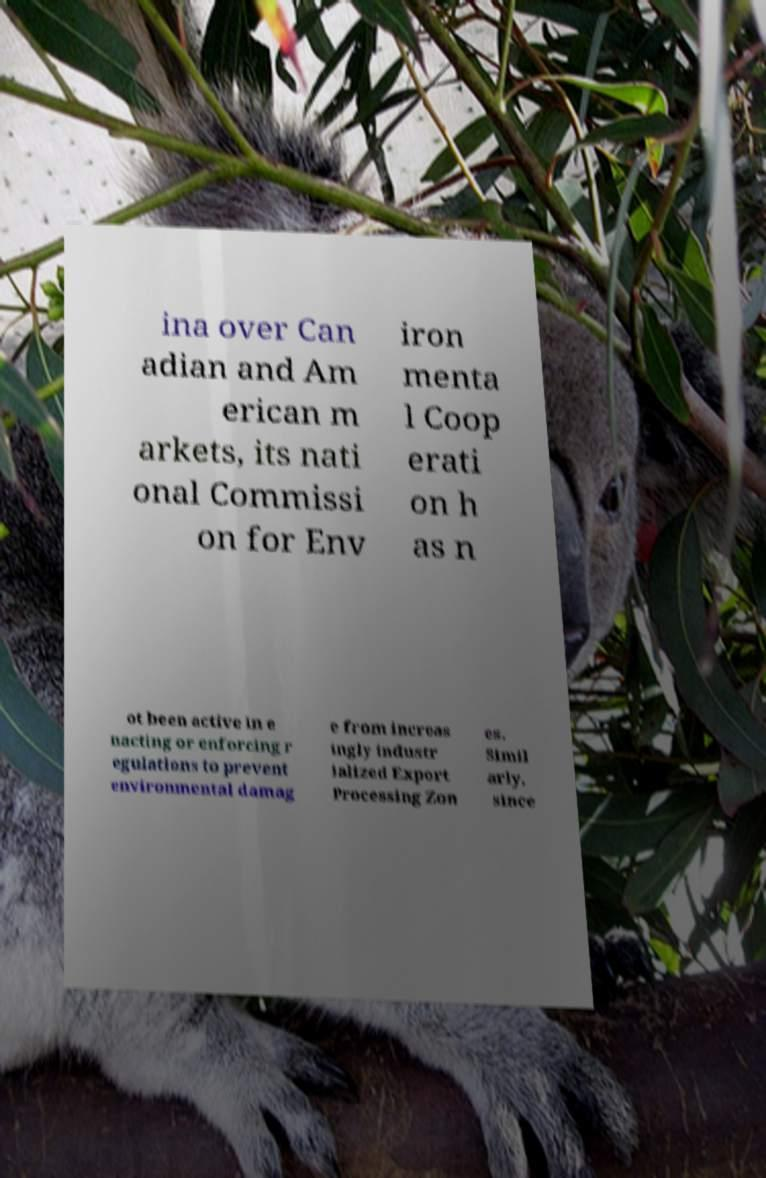Can you accurately transcribe the text from the provided image for me? ina over Can adian and Am erican m arkets, its nati onal Commissi on for Env iron menta l Coop erati on h as n ot been active in e nacting or enforcing r egulations to prevent environmental damag e from increas ingly industr ialized Export Processing Zon es. Simil arly, since 